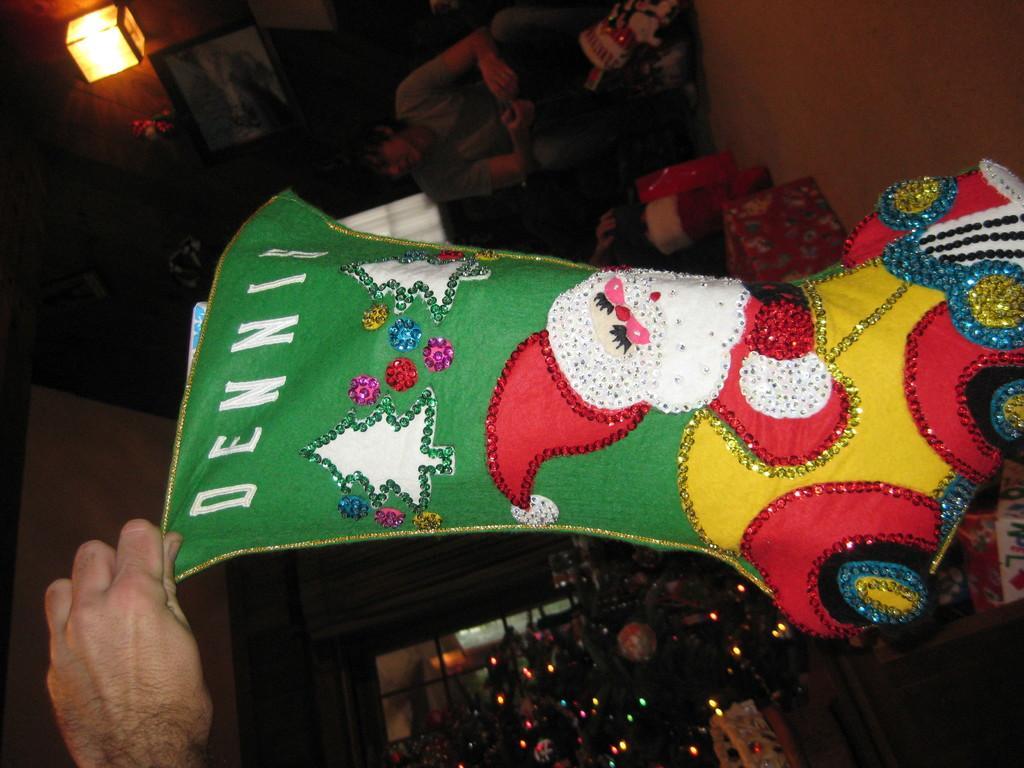Could you give a brief overview of what you see in this image? As we can see in the image there is a light, wall and few people here and there. Here there is a Christmas tree and lights. 